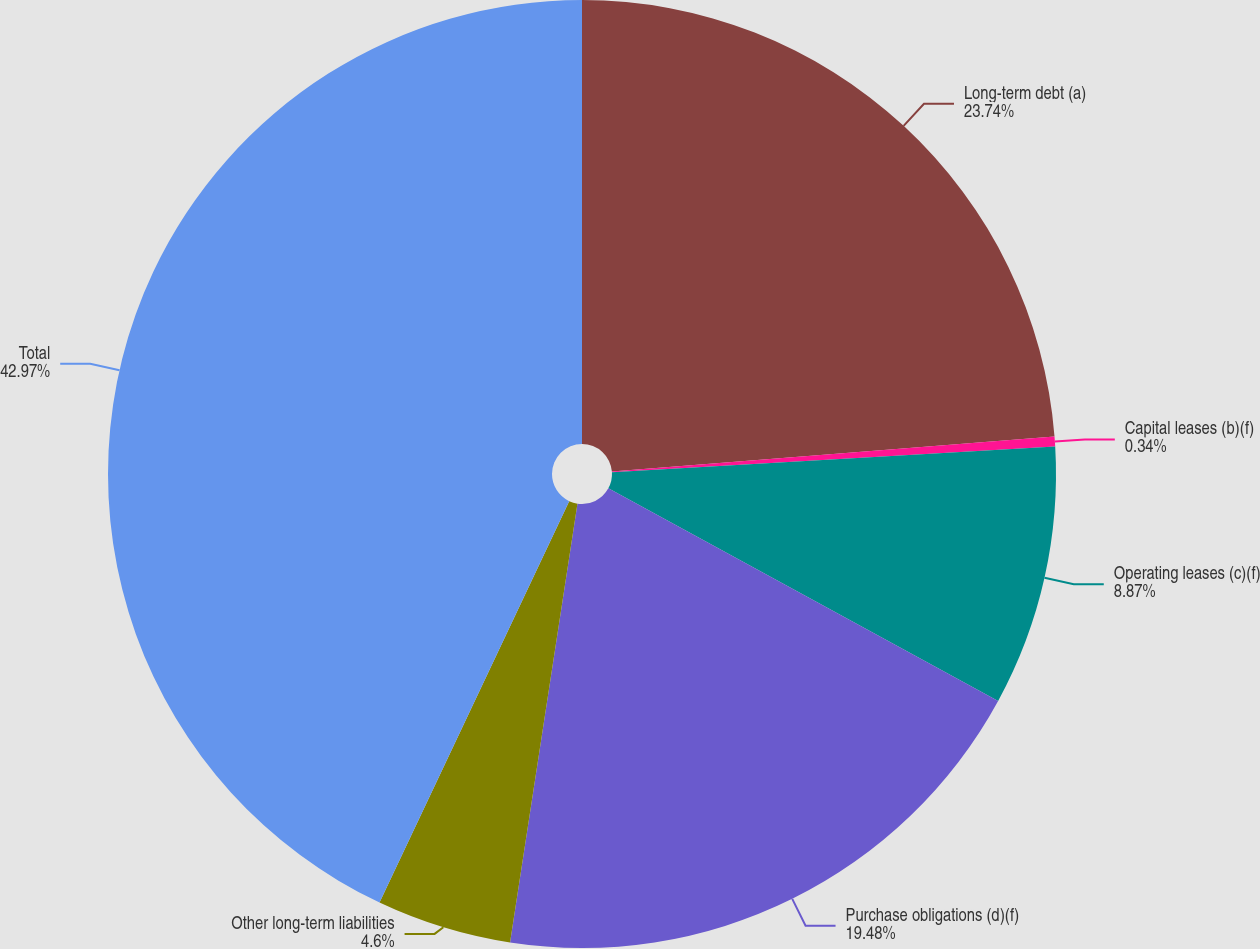<chart> <loc_0><loc_0><loc_500><loc_500><pie_chart><fcel>Long-term debt (a)<fcel>Capital leases (b)(f)<fcel>Operating leases (c)(f)<fcel>Purchase obligations (d)(f)<fcel>Other long-term liabilities<fcel>Total<nl><fcel>23.74%<fcel>0.34%<fcel>8.87%<fcel>19.48%<fcel>4.6%<fcel>42.98%<nl></chart> 